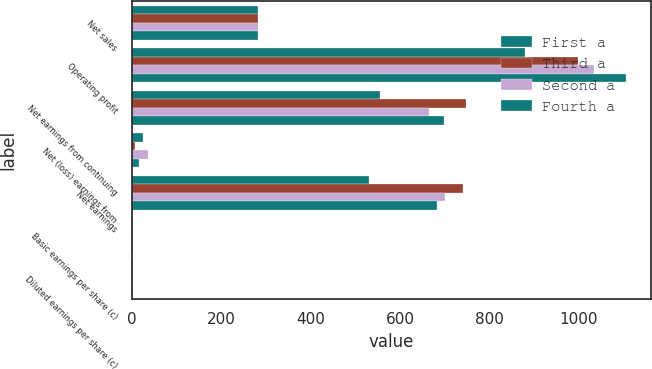<chart> <loc_0><loc_0><loc_500><loc_500><stacked_bar_chart><ecel><fcel>Net sales<fcel>Operating profit<fcel>Net earnings from continuing<fcel>Net (loss) earnings from<fcel>Net earnings<fcel>Basic earnings per share (c)<fcel>Diluted earnings per share (c)<nl><fcel>First a<fcel>282.5<fcel>880<fcel>556<fcel>26<fcel>530<fcel>1.52<fcel>1.5<nl><fcel>Third a<fcel>282.5<fcel>999<fcel>748<fcel>6<fcel>742<fcel>2.16<fcel>2.14<nl><fcel>Second a<fcel>282.5<fcel>1035<fcel>665<fcel>35<fcel>700<fcel>2.12<fcel>2.1<nl><fcel>Fourth a<fcel>282.5<fcel>1106<fcel>698<fcel>15<fcel>683<fcel>2.12<fcel>2.09<nl></chart> 